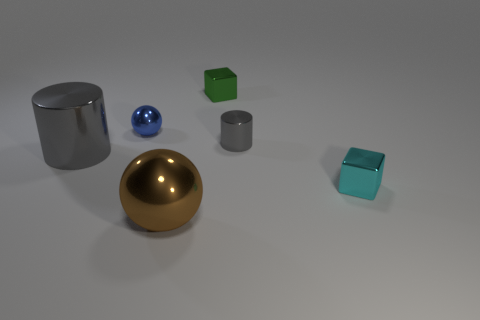There is a brown shiny thing that is the same shape as the small blue object; what is its size?
Provide a short and direct response. Large. How big is the cube on the left side of the cube that is to the right of the small green metallic thing?
Your answer should be compact. Small. Are there an equal number of tiny metallic objects that are in front of the cyan metallic cube and brown cylinders?
Your answer should be very brief. Yes. How many other things are there of the same color as the small cylinder?
Give a very brief answer. 1. Is the number of big brown balls on the left side of the large metallic cylinder less than the number of large spheres?
Keep it short and to the point. Yes. Is there a gray metallic cylinder of the same size as the green thing?
Offer a very short reply. Yes. There is a tiny cylinder; is its color the same as the big metallic thing behind the small cyan metal thing?
Keep it short and to the point. Yes. There is a small metal thing to the left of the green cube; what number of tiny green things are on the right side of it?
Provide a succinct answer. 1. The ball behind the tiny metallic block in front of the blue thing is what color?
Your answer should be very brief. Blue. What is the object that is in front of the big metallic cylinder and behind the big brown ball made of?
Provide a succinct answer. Metal. 